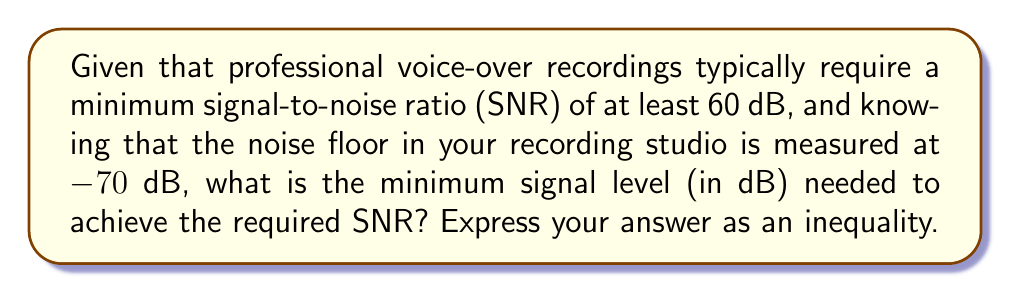Give your solution to this math problem. Let's approach this step-by-step:

1) The signal-to-noise ratio (SNR) is defined as the difference between the signal level and the noise floor:

   $$ SNR = Signal_{level} - Noise_{floor} $$

2) We're given that the minimum required SNR is 60 dB:

   $$ SNR \geq 60 \text{ dB} $$

3) We're also told that the noise floor is -70 dB. Let's call the signal level $x$ dB. Substituting these into our SNR equation:

   $$ x - (-70) \geq 60 $$

4) Simplify by removing the double negative:

   $$ x + 70 \geq 60 $$

5) Subtract 70 from both sides:

   $$ x \geq 60 - 70 $$

6) Simplify:

   $$ x \geq -10 $$

Therefore, the minimum signal level needed is any value greater than or equal to -10 dB.
Answer: $x \geq -10$ dB 